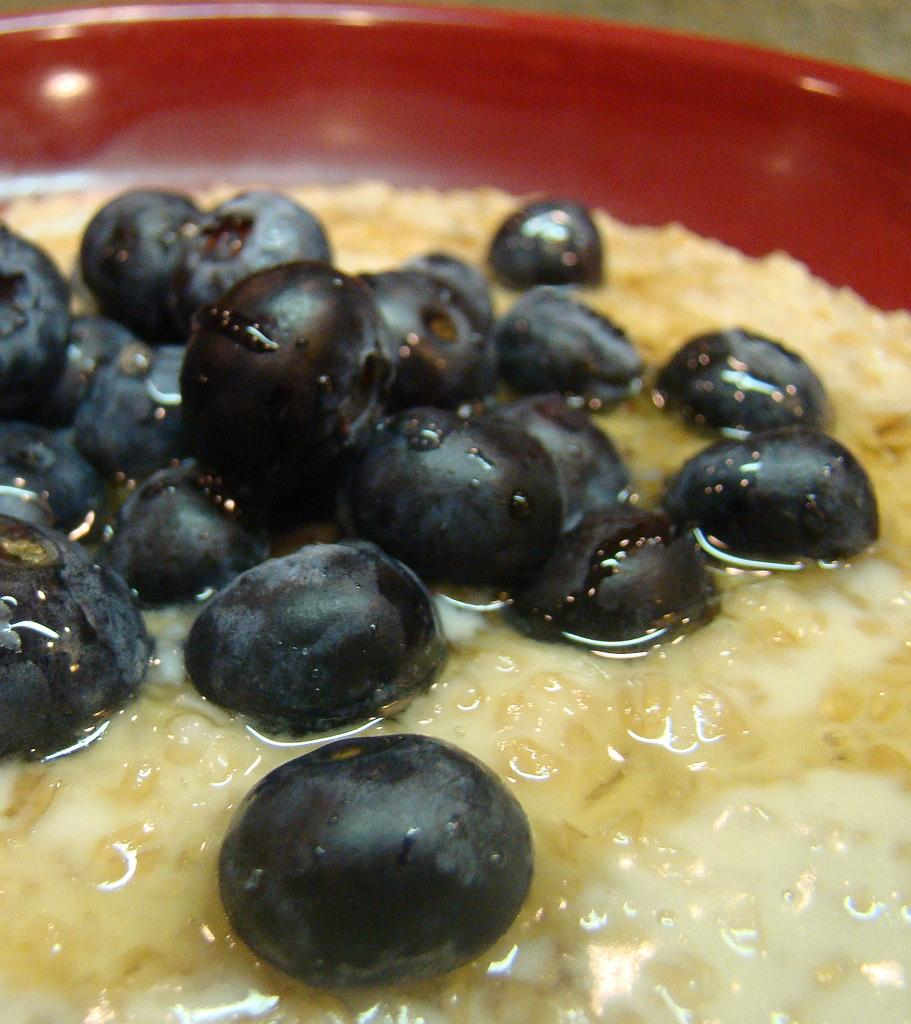What is located in the center of the image? There is a bowl in the center of the image. What is inside the bowl? The bowl contains grapes and other food items. What idea is being expressed in the verse written on the grapes in the image? There is no verse written on the grapes in the image, so it is not possible to answer that question. 